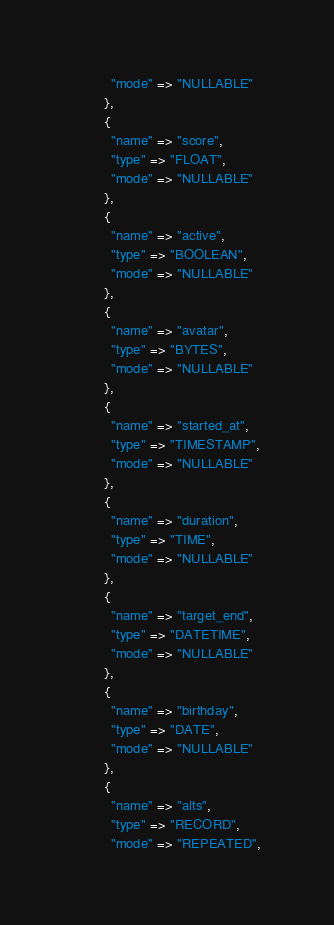Convert code to text. <code><loc_0><loc_0><loc_500><loc_500><_Ruby_>          "mode" => "NULLABLE"
        },
        {
          "name" => "score",
          "type" => "FLOAT",
          "mode" => "NULLABLE"
        },
        {
          "name" => "active",
          "type" => "BOOLEAN",
          "mode" => "NULLABLE"
        },
        {
          "name" => "avatar",
          "type" => "BYTES",
          "mode" => "NULLABLE"
        },
        {
          "name" => "started_at",
          "type" => "TIMESTAMP",
          "mode" => "NULLABLE"
        },
        {
          "name" => "duration",
          "type" => "TIME",
          "mode" => "NULLABLE"
        },
        {
          "name" => "target_end",
          "type" => "DATETIME",
          "mode" => "NULLABLE"
        },
        {
          "name" => "birthday",
          "type" => "DATE",
          "mode" => "NULLABLE"
        },
        {
          "name" => "alts",
          "type" => "RECORD",
          "mode" => "REPEATED",</code> 